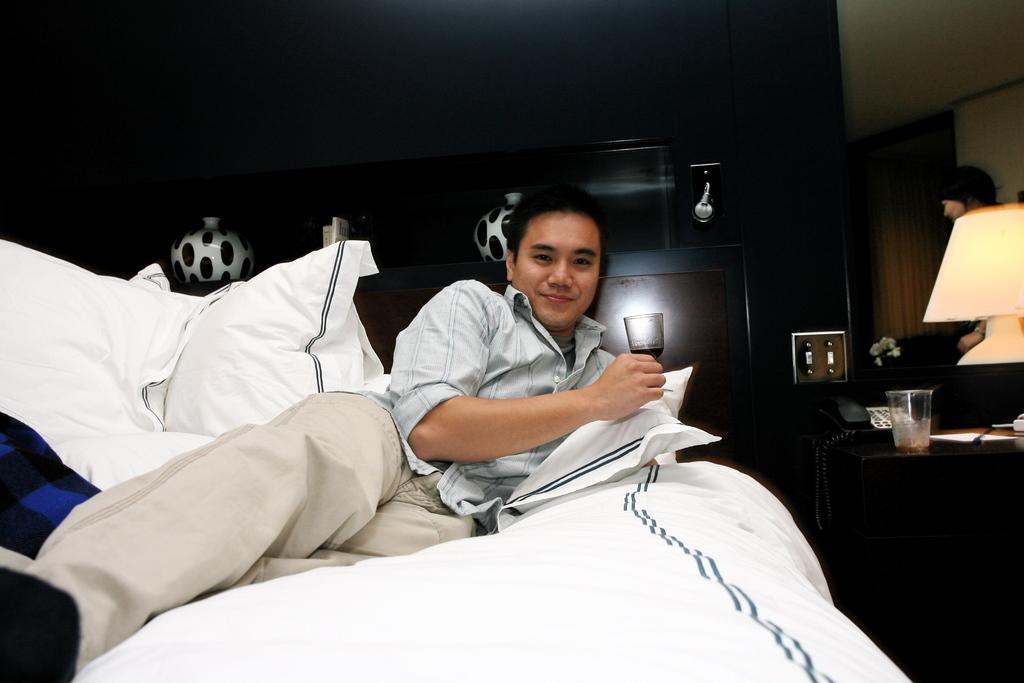What is the man in the image doing? The man is laying on the bed. What is present on the bed besides the man? There are two pillows on the bed. What can be seen near the bed in the image? There is a bed lamp in the image. What is located on a table in the image? There is a glass on a table in the image. What type of journey is the man embarking on in the image? There is no indication of a journey in the image; the man is simply laying on the bed. 